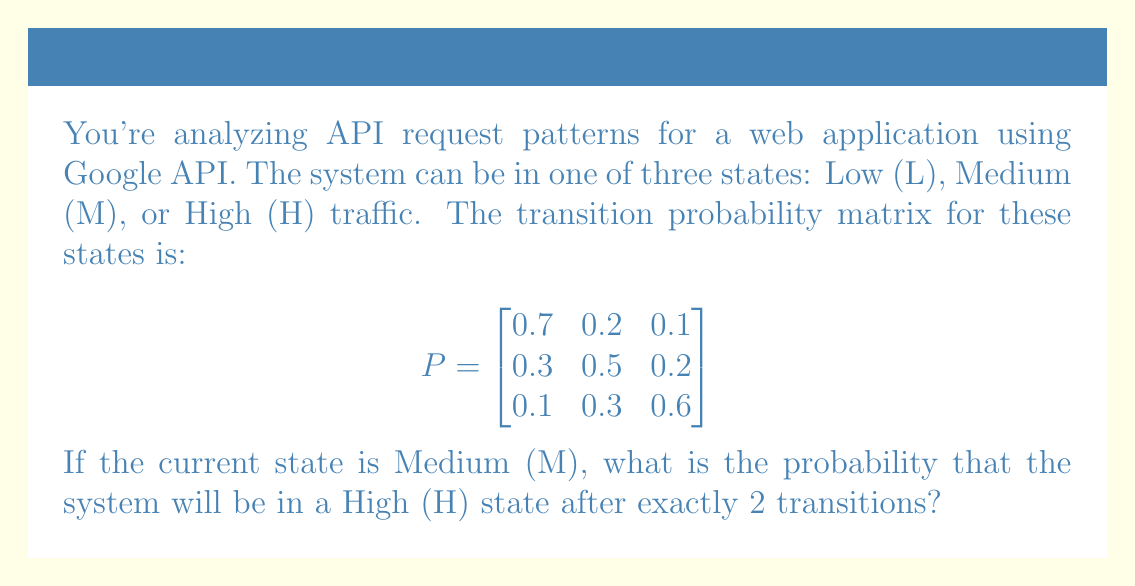Show me your answer to this math problem. Let's approach this step-by-step using Markov chain properties:

1) The initial state vector for Medium (M) is:
   $v_0 = \begin{bmatrix} 0 & 1 & 0 \end{bmatrix}$

2) To find the state after 2 transitions, we need to multiply the initial state vector by the transition matrix twice:
   $v_2 = v_0 \cdot P^2$

3) Let's calculate $P^2$:
   $$P^2 = \begin{bmatrix}
   0.7 & 0.2 & 0.1 \\
   0.3 & 0.5 & 0.2 \\
   0.1 & 0.3 & 0.6
   \end{bmatrix} \cdot 
   \begin{bmatrix}
   0.7 & 0.2 & 0.1 \\
   0.3 & 0.5 & 0.2 \\
   0.1 & 0.3 & 0.6
   \end{bmatrix}$$

4) Multiplying these matrices:
   $$P^2 = \begin{bmatrix}
   0.56 & 0.29 & 0.15 \\
   0.37 & 0.41 & 0.22 \\
   0.22 & 0.39 & 0.39
   \end{bmatrix}$$

5) Now, we multiply the initial state vector by $P^2$:
   $v_2 = \begin{bmatrix} 0 & 1 & 0 \end{bmatrix} \cdot 
   \begin{bmatrix}
   0.56 & 0.29 & 0.15 \\
   0.37 & 0.41 & 0.22 \\
   0.22 & 0.39 & 0.39
   \end{bmatrix}$

6) This gives us:
   $v_2 = \begin{bmatrix} 0.37 & 0.41 & 0.22 \end{bmatrix}$

7) The probability of being in the High (H) state after 2 transitions is the third element of this vector: 0.22 or 22%.
Answer: 0.22 